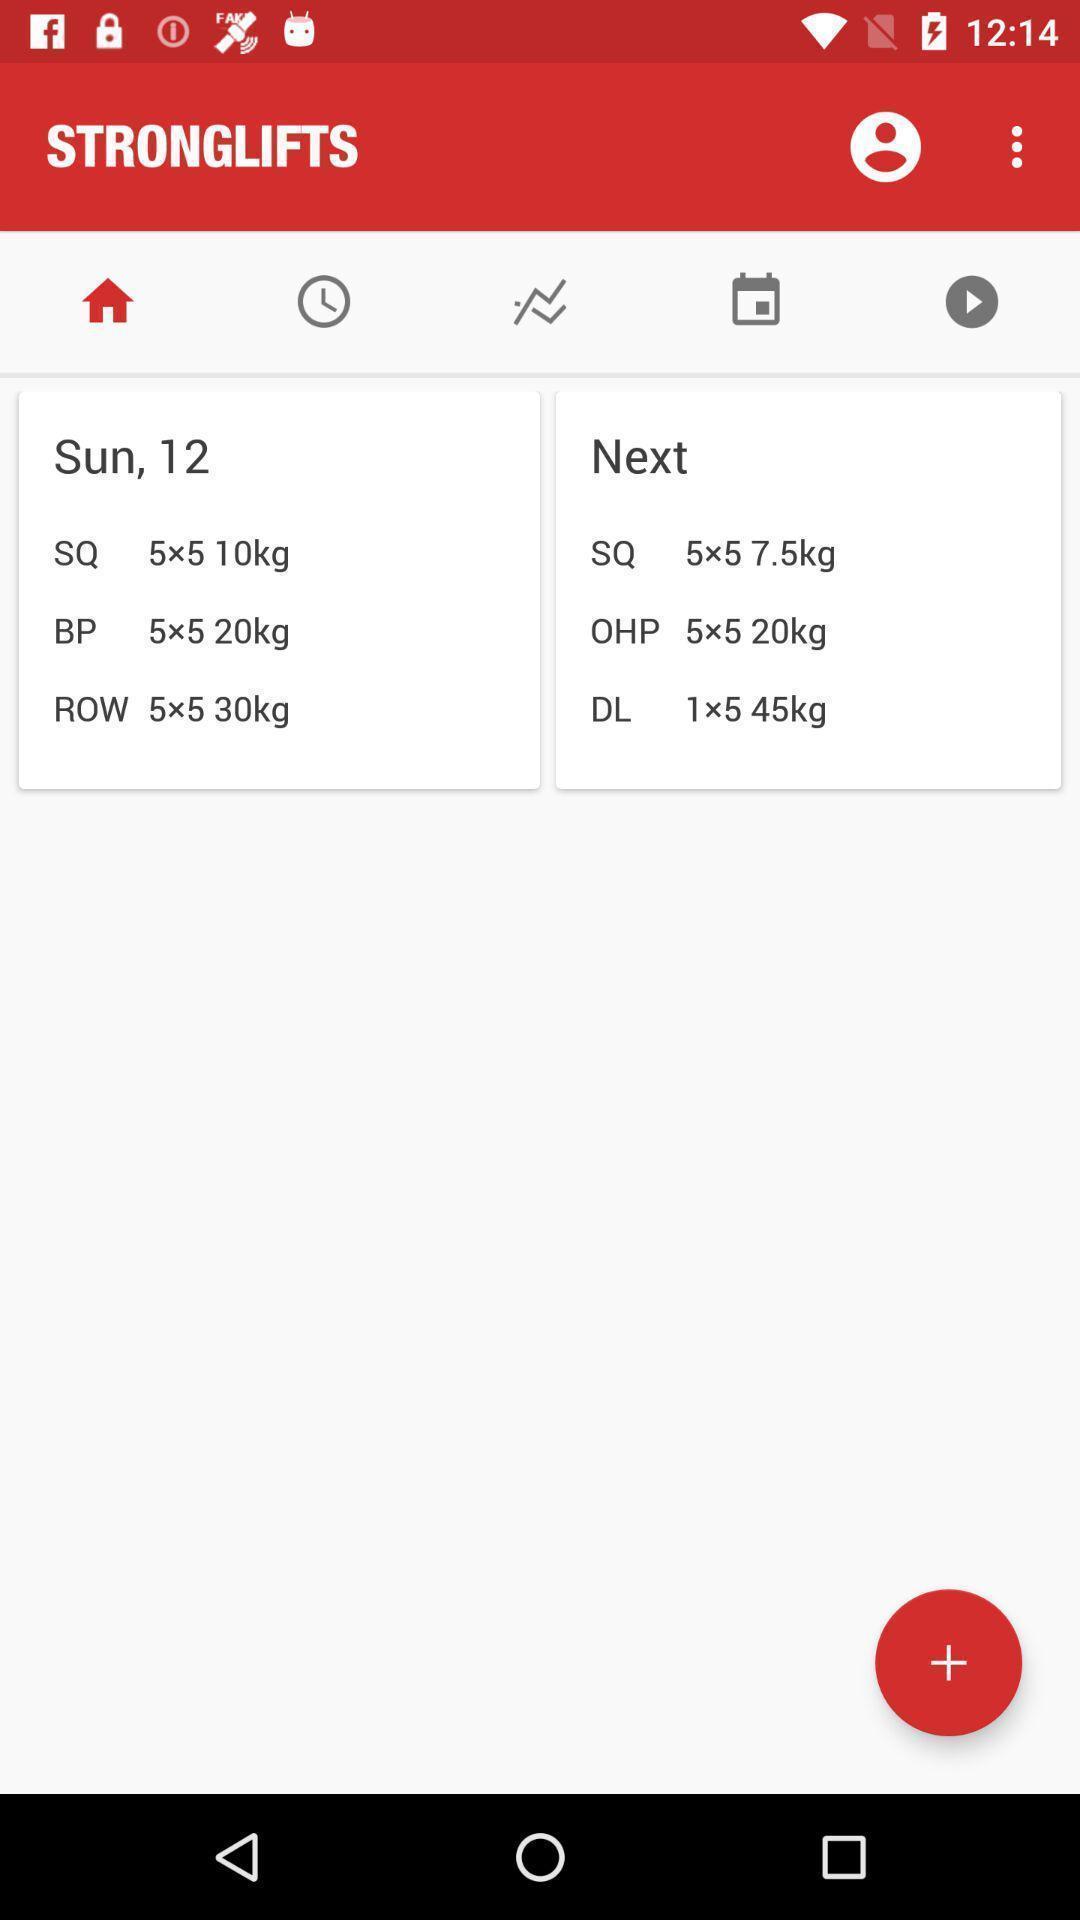Describe the content in this image. Page for fitness app with some information. 